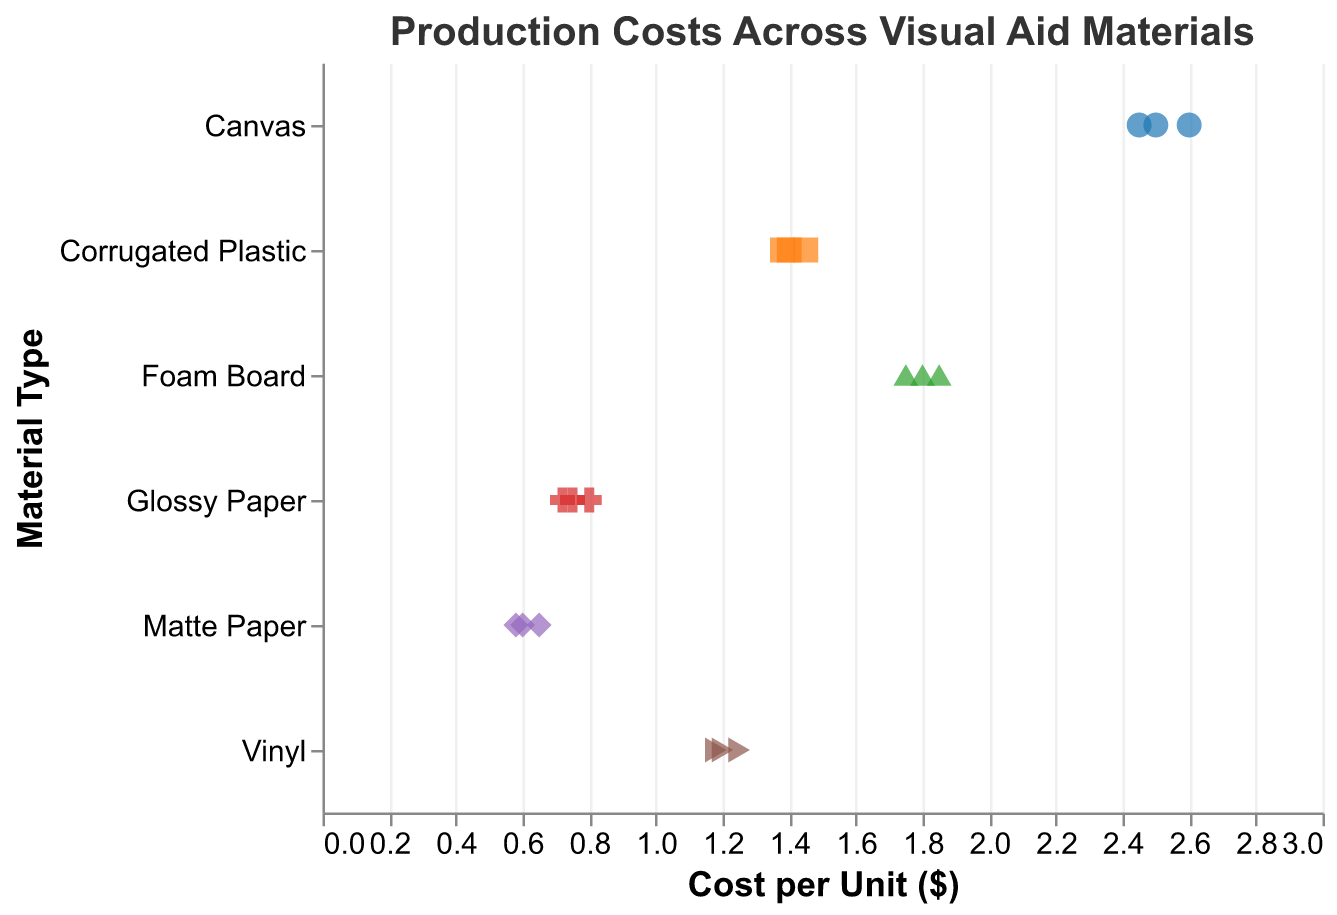What's the title of the figure? The title of the figure is displayed at the top, which states "Production Costs Across Visual Aid Materials".
Answer: Production Costs Across Visual Aid Materials How many data points are there for each material? The strip plot shows multiple points for each material: Glossy Paper, Matte Paper, Vinyl, Canvas, Foam Board, and Corrugated Plastic. Each has been repeated three times, indicating 3 data points per material.
Answer: 3 Which material has the highest average production cost? To find the material with the highest average cost, calculate the average cost per unit for all materials: 
- Glossy Paper: (0.75 + 0.80 + 0.72)/3 = 0.76 
- Matte Paper: (0.60 + 0.65 + 0.58)/3 = 0.61 
- Vinyl: (1.20 + 1.25 + 1.18)/3 = 1.21 
- Canvas: (2.50 + 2.60 + 2.45)/3 = 2.52 
- Foam Board: (1.80 + 1.85 + 1.75)/3 = 1.80 
- Corrugated Plastic: (1.40 + 1.45 + 1.38)/3 = 1.41
Canvas has the highest average production cost.
Answer: Canvas What is the range of production costs for Matte Paper? To determine the range, subtract the minimum cost from the maximum cost for Matte Paper: Max = 0.65, Min = 0.58; Range = 0.65 - 0.58.
Answer: 0.07 Which material has the greatest spread in production costs? The spread can be identified by the difference between the maximum and minimum costs:
- Glossy Paper: 0.80 - 0.72 = 0.08
- Matte Paper: 0.65 - 0.58 = 0.07
- Vinyl: 1.25 - 1.18 = 0.07
- Canvas: 2.60 - 2.45 = 0.15
- Foam Board: 1.85 - 1.75 = 0.10
- Corrugated Plastic: 1.45 - 1.38 = 0.07
Canvas has the greatest spread.
Answer: Canvas Which material is the least expensive in terms of average production cost? To find the least expensive material, compare the average costs computed previously:
- Glossy Paper: 0.76 
- Matte Paper: 0.61 
- Vinyl: 1.21 
- Canvas: 2.52 
- Foam Board: 1.80 
- Corrugated Plastic: 1.41
Matte Paper has the lowest average production cost.
Answer: Matte Paper What shapes are used to represent different materials in the strip plot? The strip plot uses different shapes to represent materials, which can be observed visually by distinguishing between various points.
Answer: Various What is the maximum production cost for Corrugated Plastic? Look for the highest point associated with Corrugated Plastic along the x-axis, which is 1.45.
Answer: 1.45 